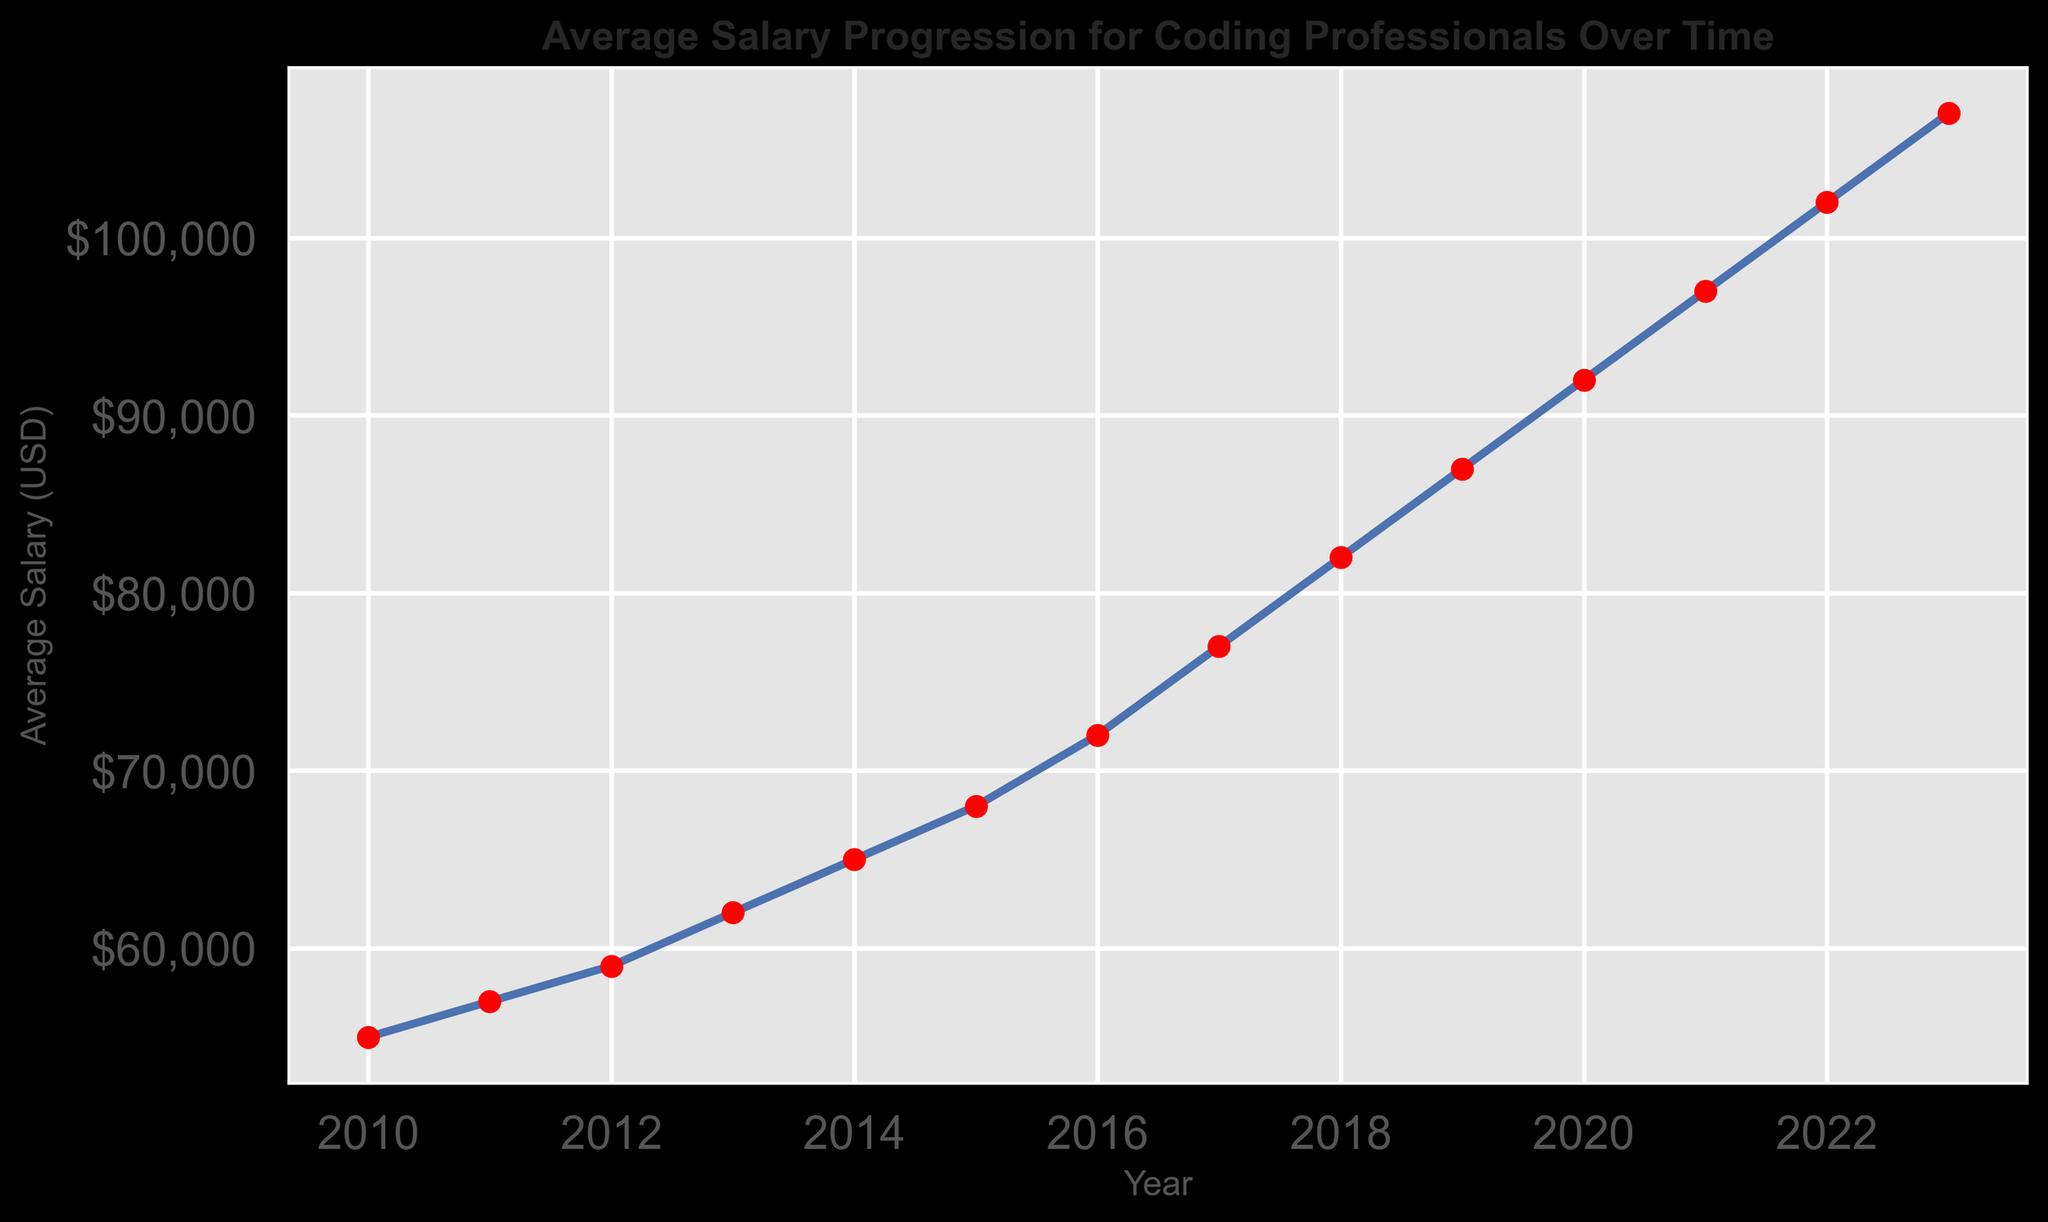What was the average salary of coding professionals in 2016? Refer to the figure and look for the data point corresponding to the year 2016 on the x-axis. The y-axis value for this data point represents the average salary in 2016.
Answer: $72,000 By how much did the average salary increase from 2010 to 2023? Find the average salary values for both 2010 and 2023 on the y-axis. Subtract the 2010 value from the 2023 value to find the increase.
Answer: $52,000 What is the average annual increase in salary from 2010 to 2023? First, find the total salary increase from 2010 to 2023 (which is $52,000). Next, determine the number of years between 2010 and 2023, which is 13 years. Finally, divide the total increase by the number of years.
Answer: $4,000 In which year did the average salary exceed $80,000 for the first time? Locate the point on the figure where the average salary surpasses $80,000. Identify the corresponding year on the x-axis.
Answer: 2018 By how much did the average salary increase from 2014 to 2017? Reference the figure to find the average salary values for 2014 and 2017. Subtract the 2014 value from the 2017 value.
Answer: $12,000 Which year experienced the highest salary increase compared to the previous year? Observe the figure and compare annual increases. Identify the year with the most significant rise between two consecutive points.
Answer: 2017 What was the salary difference between the highest and the lowest years? Identify the highest and lowest average salaries from the figure (2023 and 2010, respectively). Subtract the lowest value from the highest value.
Answer: $52,000 Is the trendline generally increasing, decreasing, or stable? Examine the general direction of the line plot over the years.
Answer: Increasing How does the salary progression between 2015 and 2020 compare to the progression between 2020 and 2023? Find the salary differences for both periods. The first period (2015-2020): $92,000 - $68,000; the second period (2020-2023): $107,000 - $92,000. Compare the two differences.
Answer: Both periods show an increase, but the increase from 2015 to 2020 ($24,000) is larger than from 2020 to 2023 ($15,000) What is the most noticeable visual feature of the line plot? Examine the visual attributes of the plot, such as colors, markers, line styles, or significant changes in trends.
Answer: The blue line with red markers and the consistent upward trend 